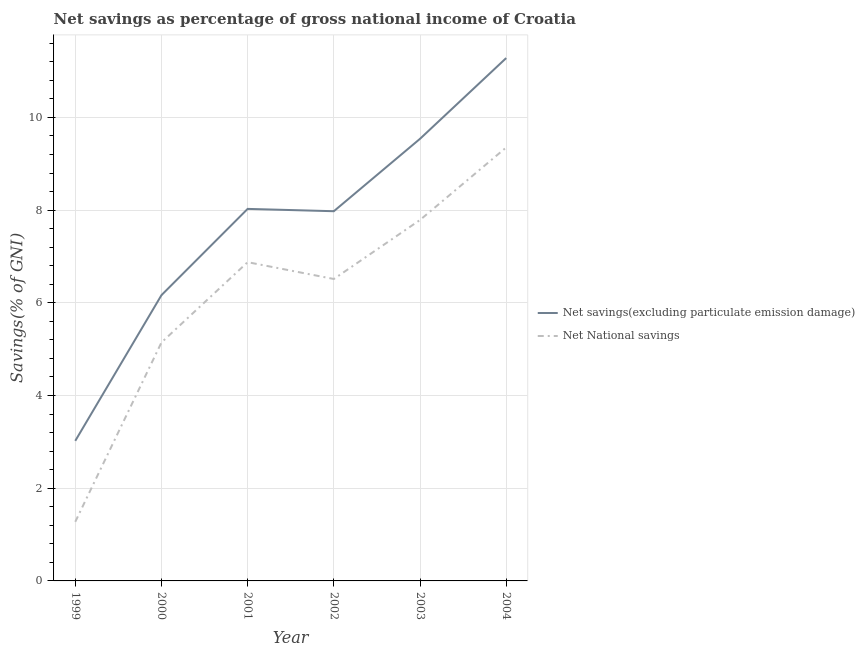Is the number of lines equal to the number of legend labels?
Provide a succinct answer. Yes. What is the net savings(excluding particulate emission damage) in 2000?
Your answer should be compact. 6.16. Across all years, what is the maximum net savings(excluding particulate emission damage)?
Keep it short and to the point. 11.28. Across all years, what is the minimum net savings(excluding particulate emission damage)?
Provide a short and direct response. 3.02. In which year was the net savings(excluding particulate emission damage) maximum?
Keep it short and to the point. 2004. In which year was the net national savings minimum?
Provide a short and direct response. 1999. What is the total net national savings in the graph?
Make the answer very short. 36.95. What is the difference between the net national savings in 1999 and that in 2004?
Your answer should be very brief. -8.08. What is the difference between the net savings(excluding particulate emission damage) in 2001 and the net national savings in 2002?
Your answer should be very brief. 1.51. What is the average net savings(excluding particulate emission damage) per year?
Offer a very short reply. 7.67. In the year 2000, what is the difference between the net national savings and net savings(excluding particulate emission damage)?
Offer a terse response. -1.02. What is the ratio of the net national savings in 2000 to that in 2004?
Offer a terse response. 0.55. Is the net national savings in 2000 less than that in 2004?
Offer a terse response. Yes. What is the difference between the highest and the second highest net savings(excluding particulate emission damage)?
Offer a terse response. 1.74. What is the difference between the highest and the lowest net national savings?
Your response must be concise. 8.08. Does the net savings(excluding particulate emission damage) monotonically increase over the years?
Your response must be concise. No. Where does the legend appear in the graph?
Ensure brevity in your answer.  Center right. How many legend labels are there?
Provide a succinct answer. 2. How are the legend labels stacked?
Keep it short and to the point. Vertical. What is the title of the graph?
Your answer should be compact. Net savings as percentage of gross national income of Croatia. What is the label or title of the X-axis?
Provide a succinct answer. Year. What is the label or title of the Y-axis?
Your answer should be very brief. Savings(% of GNI). What is the Savings(% of GNI) in Net savings(excluding particulate emission damage) in 1999?
Provide a short and direct response. 3.02. What is the Savings(% of GNI) in Net National savings in 1999?
Provide a succinct answer. 1.28. What is the Savings(% of GNI) in Net savings(excluding particulate emission damage) in 2000?
Ensure brevity in your answer.  6.16. What is the Savings(% of GNI) in Net National savings in 2000?
Your answer should be very brief. 5.14. What is the Savings(% of GNI) of Net savings(excluding particulate emission damage) in 2001?
Offer a terse response. 8.03. What is the Savings(% of GNI) in Net National savings in 2001?
Offer a terse response. 6.88. What is the Savings(% of GNI) in Net savings(excluding particulate emission damage) in 2002?
Offer a terse response. 7.98. What is the Savings(% of GNI) of Net National savings in 2002?
Your answer should be very brief. 6.51. What is the Savings(% of GNI) in Net savings(excluding particulate emission damage) in 2003?
Offer a terse response. 9.54. What is the Savings(% of GNI) in Net National savings in 2003?
Provide a succinct answer. 7.79. What is the Savings(% of GNI) in Net savings(excluding particulate emission damage) in 2004?
Ensure brevity in your answer.  11.28. What is the Savings(% of GNI) in Net National savings in 2004?
Offer a very short reply. 9.35. Across all years, what is the maximum Savings(% of GNI) in Net savings(excluding particulate emission damage)?
Keep it short and to the point. 11.28. Across all years, what is the maximum Savings(% of GNI) of Net National savings?
Provide a short and direct response. 9.35. Across all years, what is the minimum Savings(% of GNI) in Net savings(excluding particulate emission damage)?
Offer a terse response. 3.02. Across all years, what is the minimum Savings(% of GNI) of Net National savings?
Keep it short and to the point. 1.28. What is the total Savings(% of GNI) of Net savings(excluding particulate emission damage) in the graph?
Make the answer very short. 46.01. What is the total Savings(% of GNI) of Net National savings in the graph?
Give a very brief answer. 36.95. What is the difference between the Savings(% of GNI) of Net savings(excluding particulate emission damage) in 1999 and that in 2000?
Your response must be concise. -3.14. What is the difference between the Savings(% of GNI) in Net National savings in 1999 and that in 2000?
Offer a very short reply. -3.87. What is the difference between the Savings(% of GNI) of Net savings(excluding particulate emission damage) in 1999 and that in 2001?
Your response must be concise. -5. What is the difference between the Savings(% of GNI) in Net National savings in 1999 and that in 2001?
Your answer should be compact. -5.6. What is the difference between the Savings(% of GNI) in Net savings(excluding particulate emission damage) in 1999 and that in 2002?
Your answer should be compact. -4.95. What is the difference between the Savings(% of GNI) in Net National savings in 1999 and that in 2002?
Make the answer very short. -5.24. What is the difference between the Savings(% of GNI) of Net savings(excluding particulate emission damage) in 1999 and that in 2003?
Offer a terse response. -6.52. What is the difference between the Savings(% of GNI) of Net National savings in 1999 and that in 2003?
Offer a very short reply. -6.51. What is the difference between the Savings(% of GNI) of Net savings(excluding particulate emission damage) in 1999 and that in 2004?
Provide a short and direct response. -8.26. What is the difference between the Savings(% of GNI) in Net National savings in 1999 and that in 2004?
Offer a very short reply. -8.08. What is the difference between the Savings(% of GNI) in Net savings(excluding particulate emission damage) in 2000 and that in 2001?
Ensure brevity in your answer.  -1.86. What is the difference between the Savings(% of GNI) of Net National savings in 2000 and that in 2001?
Offer a terse response. -1.73. What is the difference between the Savings(% of GNI) of Net savings(excluding particulate emission damage) in 2000 and that in 2002?
Your answer should be very brief. -1.81. What is the difference between the Savings(% of GNI) of Net National savings in 2000 and that in 2002?
Provide a succinct answer. -1.37. What is the difference between the Savings(% of GNI) in Net savings(excluding particulate emission damage) in 2000 and that in 2003?
Keep it short and to the point. -3.37. What is the difference between the Savings(% of GNI) in Net National savings in 2000 and that in 2003?
Offer a terse response. -2.64. What is the difference between the Savings(% of GNI) in Net savings(excluding particulate emission damage) in 2000 and that in 2004?
Provide a short and direct response. -5.12. What is the difference between the Savings(% of GNI) of Net National savings in 2000 and that in 2004?
Your answer should be very brief. -4.21. What is the difference between the Savings(% of GNI) in Net savings(excluding particulate emission damage) in 2001 and that in 2002?
Make the answer very short. 0.05. What is the difference between the Savings(% of GNI) in Net National savings in 2001 and that in 2002?
Your answer should be compact. 0.36. What is the difference between the Savings(% of GNI) of Net savings(excluding particulate emission damage) in 2001 and that in 2003?
Provide a succinct answer. -1.51. What is the difference between the Savings(% of GNI) in Net National savings in 2001 and that in 2003?
Offer a very short reply. -0.91. What is the difference between the Savings(% of GNI) of Net savings(excluding particulate emission damage) in 2001 and that in 2004?
Offer a terse response. -3.25. What is the difference between the Savings(% of GNI) in Net National savings in 2001 and that in 2004?
Provide a short and direct response. -2.47. What is the difference between the Savings(% of GNI) of Net savings(excluding particulate emission damage) in 2002 and that in 2003?
Your answer should be compact. -1.56. What is the difference between the Savings(% of GNI) in Net National savings in 2002 and that in 2003?
Ensure brevity in your answer.  -1.27. What is the difference between the Savings(% of GNI) in Net savings(excluding particulate emission damage) in 2002 and that in 2004?
Your response must be concise. -3.3. What is the difference between the Savings(% of GNI) in Net National savings in 2002 and that in 2004?
Make the answer very short. -2.84. What is the difference between the Savings(% of GNI) in Net savings(excluding particulate emission damage) in 2003 and that in 2004?
Your answer should be very brief. -1.74. What is the difference between the Savings(% of GNI) in Net National savings in 2003 and that in 2004?
Keep it short and to the point. -1.56. What is the difference between the Savings(% of GNI) of Net savings(excluding particulate emission damage) in 1999 and the Savings(% of GNI) of Net National savings in 2000?
Your response must be concise. -2.12. What is the difference between the Savings(% of GNI) in Net savings(excluding particulate emission damage) in 1999 and the Savings(% of GNI) in Net National savings in 2001?
Give a very brief answer. -3.85. What is the difference between the Savings(% of GNI) in Net savings(excluding particulate emission damage) in 1999 and the Savings(% of GNI) in Net National savings in 2002?
Ensure brevity in your answer.  -3.49. What is the difference between the Savings(% of GNI) in Net savings(excluding particulate emission damage) in 1999 and the Savings(% of GNI) in Net National savings in 2003?
Ensure brevity in your answer.  -4.77. What is the difference between the Savings(% of GNI) in Net savings(excluding particulate emission damage) in 1999 and the Savings(% of GNI) in Net National savings in 2004?
Offer a terse response. -6.33. What is the difference between the Savings(% of GNI) in Net savings(excluding particulate emission damage) in 2000 and the Savings(% of GNI) in Net National savings in 2001?
Your answer should be compact. -0.71. What is the difference between the Savings(% of GNI) in Net savings(excluding particulate emission damage) in 2000 and the Savings(% of GNI) in Net National savings in 2002?
Provide a succinct answer. -0.35. What is the difference between the Savings(% of GNI) of Net savings(excluding particulate emission damage) in 2000 and the Savings(% of GNI) of Net National savings in 2003?
Offer a very short reply. -1.62. What is the difference between the Savings(% of GNI) in Net savings(excluding particulate emission damage) in 2000 and the Savings(% of GNI) in Net National savings in 2004?
Keep it short and to the point. -3.19. What is the difference between the Savings(% of GNI) of Net savings(excluding particulate emission damage) in 2001 and the Savings(% of GNI) of Net National savings in 2002?
Offer a terse response. 1.51. What is the difference between the Savings(% of GNI) of Net savings(excluding particulate emission damage) in 2001 and the Savings(% of GNI) of Net National savings in 2003?
Your response must be concise. 0.24. What is the difference between the Savings(% of GNI) in Net savings(excluding particulate emission damage) in 2001 and the Savings(% of GNI) in Net National savings in 2004?
Your response must be concise. -1.33. What is the difference between the Savings(% of GNI) of Net savings(excluding particulate emission damage) in 2002 and the Savings(% of GNI) of Net National savings in 2003?
Your response must be concise. 0.19. What is the difference between the Savings(% of GNI) of Net savings(excluding particulate emission damage) in 2002 and the Savings(% of GNI) of Net National savings in 2004?
Provide a succinct answer. -1.38. What is the difference between the Savings(% of GNI) of Net savings(excluding particulate emission damage) in 2003 and the Savings(% of GNI) of Net National savings in 2004?
Provide a succinct answer. 0.19. What is the average Savings(% of GNI) in Net savings(excluding particulate emission damage) per year?
Offer a terse response. 7.67. What is the average Savings(% of GNI) in Net National savings per year?
Make the answer very short. 6.16. In the year 1999, what is the difference between the Savings(% of GNI) in Net savings(excluding particulate emission damage) and Savings(% of GNI) in Net National savings?
Ensure brevity in your answer.  1.75. In the year 2000, what is the difference between the Savings(% of GNI) of Net savings(excluding particulate emission damage) and Savings(% of GNI) of Net National savings?
Offer a terse response. 1.02. In the year 2001, what is the difference between the Savings(% of GNI) in Net savings(excluding particulate emission damage) and Savings(% of GNI) in Net National savings?
Provide a short and direct response. 1.15. In the year 2002, what is the difference between the Savings(% of GNI) of Net savings(excluding particulate emission damage) and Savings(% of GNI) of Net National savings?
Your answer should be very brief. 1.46. In the year 2003, what is the difference between the Savings(% of GNI) of Net savings(excluding particulate emission damage) and Savings(% of GNI) of Net National savings?
Your answer should be very brief. 1.75. In the year 2004, what is the difference between the Savings(% of GNI) in Net savings(excluding particulate emission damage) and Savings(% of GNI) in Net National savings?
Your answer should be compact. 1.93. What is the ratio of the Savings(% of GNI) in Net savings(excluding particulate emission damage) in 1999 to that in 2000?
Provide a succinct answer. 0.49. What is the ratio of the Savings(% of GNI) of Net National savings in 1999 to that in 2000?
Offer a very short reply. 0.25. What is the ratio of the Savings(% of GNI) in Net savings(excluding particulate emission damage) in 1999 to that in 2001?
Offer a terse response. 0.38. What is the ratio of the Savings(% of GNI) in Net National savings in 1999 to that in 2001?
Keep it short and to the point. 0.19. What is the ratio of the Savings(% of GNI) in Net savings(excluding particulate emission damage) in 1999 to that in 2002?
Keep it short and to the point. 0.38. What is the ratio of the Savings(% of GNI) in Net National savings in 1999 to that in 2002?
Make the answer very short. 0.2. What is the ratio of the Savings(% of GNI) in Net savings(excluding particulate emission damage) in 1999 to that in 2003?
Provide a short and direct response. 0.32. What is the ratio of the Savings(% of GNI) of Net National savings in 1999 to that in 2003?
Ensure brevity in your answer.  0.16. What is the ratio of the Savings(% of GNI) of Net savings(excluding particulate emission damage) in 1999 to that in 2004?
Provide a short and direct response. 0.27. What is the ratio of the Savings(% of GNI) in Net National savings in 1999 to that in 2004?
Offer a very short reply. 0.14. What is the ratio of the Savings(% of GNI) of Net savings(excluding particulate emission damage) in 2000 to that in 2001?
Provide a short and direct response. 0.77. What is the ratio of the Savings(% of GNI) in Net National savings in 2000 to that in 2001?
Your answer should be very brief. 0.75. What is the ratio of the Savings(% of GNI) in Net savings(excluding particulate emission damage) in 2000 to that in 2002?
Give a very brief answer. 0.77. What is the ratio of the Savings(% of GNI) of Net National savings in 2000 to that in 2002?
Offer a very short reply. 0.79. What is the ratio of the Savings(% of GNI) in Net savings(excluding particulate emission damage) in 2000 to that in 2003?
Your response must be concise. 0.65. What is the ratio of the Savings(% of GNI) of Net National savings in 2000 to that in 2003?
Offer a terse response. 0.66. What is the ratio of the Savings(% of GNI) of Net savings(excluding particulate emission damage) in 2000 to that in 2004?
Make the answer very short. 0.55. What is the ratio of the Savings(% of GNI) of Net National savings in 2000 to that in 2004?
Your response must be concise. 0.55. What is the ratio of the Savings(% of GNI) in Net savings(excluding particulate emission damage) in 2001 to that in 2002?
Provide a short and direct response. 1.01. What is the ratio of the Savings(% of GNI) in Net National savings in 2001 to that in 2002?
Provide a succinct answer. 1.06. What is the ratio of the Savings(% of GNI) of Net savings(excluding particulate emission damage) in 2001 to that in 2003?
Provide a succinct answer. 0.84. What is the ratio of the Savings(% of GNI) in Net National savings in 2001 to that in 2003?
Give a very brief answer. 0.88. What is the ratio of the Savings(% of GNI) of Net savings(excluding particulate emission damage) in 2001 to that in 2004?
Offer a terse response. 0.71. What is the ratio of the Savings(% of GNI) in Net National savings in 2001 to that in 2004?
Your answer should be very brief. 0.74. What is the ratio of the Savings(% of GNI) of Net savings(excluding particulate emission damage) in 2002 to that in 2003?
Make the answer very short. 0.84. What is the ratio of the Savings(% of GNI) of Net National savings in 2002 to that in 2003?
Provide a short and direct response. 0.84. What is the ratio of the Savings(% of GNI) in Net savings(excluding particulate emission damage) in 2002 to that in 2004?
Provide a succinct answer. 0.71. What is the ratio of the Savings(% of GNI) in Net National savings in 2002 to that in 2004?
Your response must be concise. 0.7. What is the ratio of the Savings(% of GNI) in Net savings(excluding particulate emission damage) in 2003 to that in 2004?
Make the answer very short. 0.85. What is the ratio of the Savings(% of GNI) of Net National savings in 2003 to that in 2004?
Offer a terse response. 0.83. What is the difference between the highest and the second highest Savings(% of GNI) in Net savings(excluding particulate emission damage)?
Provide a succinct answer. 1.74. What is the difference between the highest and the second highest Savings(% of GNI) of Net National savings?
Ensure brevity in your answer.  1.56. What is the difference between the highest and the lowest Savings(% of GNI) of Net savings(excluding particulate emission damage)?
Give a very brief answer. 8.26. What is the difference between the highest and the lowest Savings(% of GNI) in Net National savings?
Your answer should be compact. 8.08. 